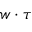Convert formula to latex. <formula><loc_0><loc_0><loc_500><loc_500>w \cdot \tau</formula> 